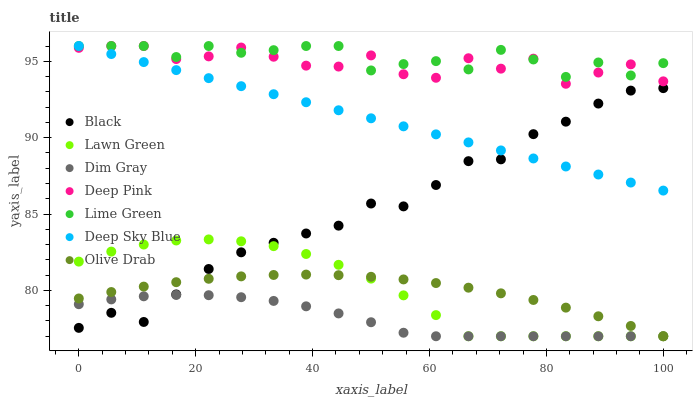Does Dim Gray have the minimum area under the curve?
Answer yes or no. Yes. Does Lime Green have the maximum area under the curve?
Answer yes or no. Yes. Does Deep Pink have the minimum area under the curve?
Answer yes or no. No. Does Deep Pink have the maximum area under the curve?
Answer yes or no. No. Is Deep Sky Blue the smoothest?
Answer yes or no. Yes. Is Deep Pink the roughest?
Answer yes or no. Yes. Is Dim Gray the smoothest?
Answer yes or no. No. Is Dim Gray the roughest?
Answer yes or no. No. Does Lawn Green have the lowest value?
Answer yes or no. Yes. Does Deep Pink have the lowest value?
Answer yes or no. No. Does Lime Green have the highest value?
Answer yes or no. Yes. Does Dim Gray have the highest value?
Answer yes or no. No. Is Olive Drab less than Lime Green?
Answer yes or no. Yes. Is Deep Pink greater than Black?
Answer yes or no. Yes. Does Lawn Green intersect Black?
Answer yes or no. Yes. Is Lawn Green less than Black?
Answer yes or no. No. Is Lawn Green greater than Black?
Answer yes or no. No. Does Olive Drab intersect Lime Green?
Answer yes or no. No. 